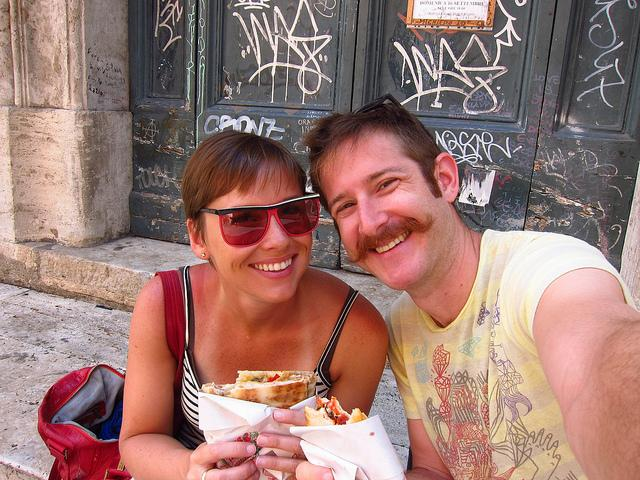Why is she covering her eyes?

Choices:
A) rain protection
B) snow protection
C) ice protection
D) sun protection sun protection 